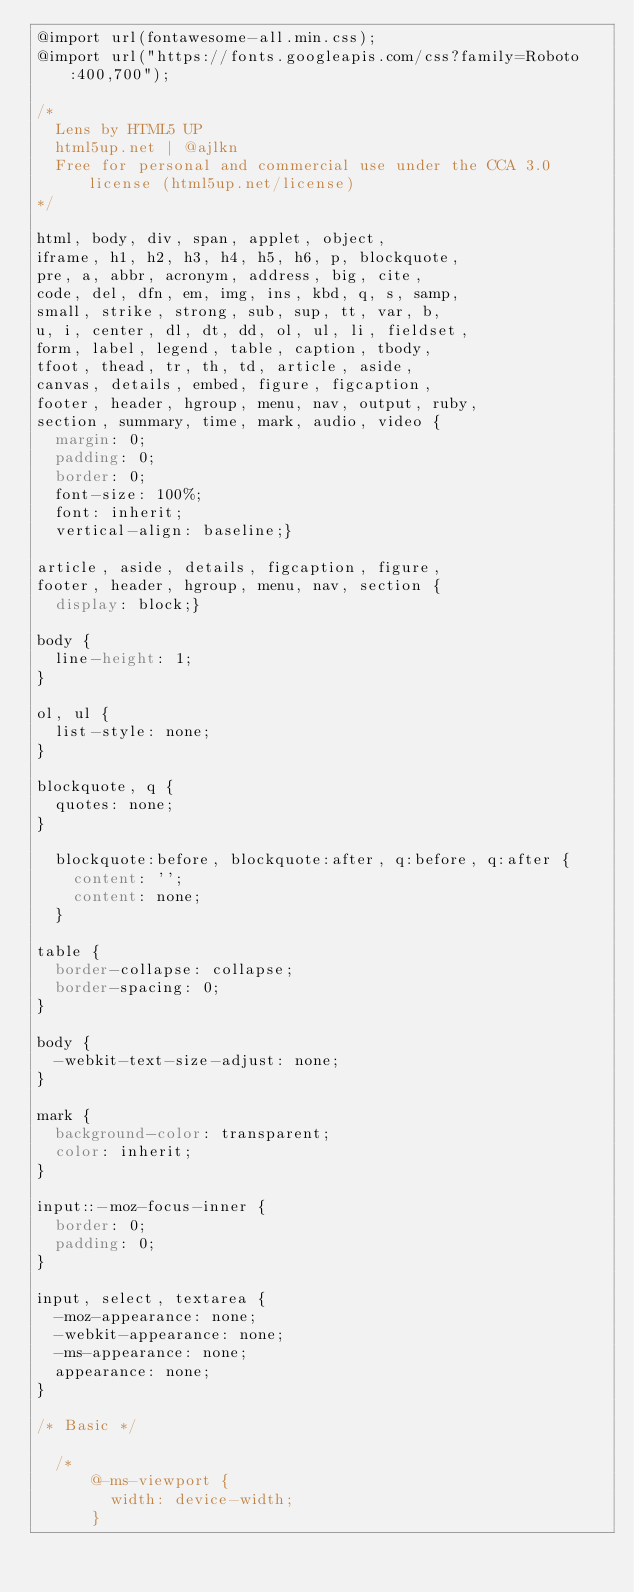Convert code to text. <code><loc_0><loc_0><loc_500><loc_500><_CSS_>@import url(fontawesome-all.min.css);
@import url("https://fonts.googleapis.com/css?family=Roboto:400,700");

/*
	Lens by HTML5 UP
	html5up.net | @ajlkn
	Free for personal and commercial use under the CCA 3.0 license (html5up.net/license)
*/

html, body, div, span, applet, object,
iframe, h1, h2, h3, h4, h5, h6, p, blockquote,
pre, a, abbr, acronym, address, big, cite,
code, del, dfn, em, img, ins, kbd, q, s, samp,
small, strike, strong, sub, sup, tt, var, b,
u, i, center, dl, dt, dd, ol, ul, li, fieldset,
form, label, legend, table, caption, tbody,
tfoot, thead, tr, th, td, article, aside,
canvas, details, embed, figure, figcaption,
footer, header, hgroup, menu, nav, output, ruby,
section, summary, time, mark, audio, video {
	margin: 0;
	padding: 0;
	border: 0;
	font-size: 100%;
	font: inherit;
	vertical-align: baseline;}

article, aside, details, figcaption, figure,
footer, header, hgroup, menu, nav, section {
	display: block;}

body {
	line-height: 1;
}

ol, ul {
	list-style: none;
}

blockquote, q {
	quotes: none;
}

	blockquote:before, blockquote:after, q:before, q:after {
		content: '';
		content: none;
	}

table {
	border-collapse: collapse;
	border-spacing: 0;
}

body {
	-webkit-text-size-adjust: none;
}

mark {
	background-color: transparent;
	color: inherit;
}

input::-moz-focus-inner {
	border: 0;
	padding: 0;
}

input, select, textarea {
	-moz-appearance: none;
	-webkit-appearance: none;
	-ms-appearance: none;
	appearance: none;
}

/* Basic */

	/*
			@-ms-viewport {
				width: device-width;
			}</code> 